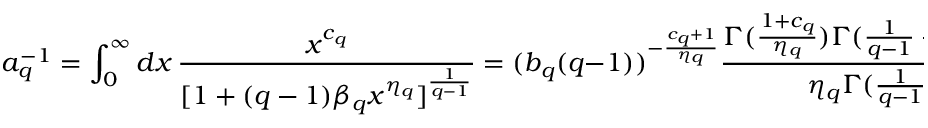Convert formula to latex. <formula><loc_0><loc_0><loc_500><loc_500>a _ { q } ^ { - 1 } = \int _ { 0 } ^ { \infty } d x \, \frac { x ^ { c _ { q } } } { [ 1 + ( q - 1 ) \beta _ { q } x ^ { \eta _ { q } } ] ^ { \frac { 1 } { q - 1 } } } = ( b _ { q } ( q - 1 ) ) ^ { - \frac { c _ { q } + 1 } { \eta _ { q } } } \frac { \Gamma ( \frac { 1 + c _ { q } } { \eta _ { q } } ) \Gamma ( \frac { 1 } { q - 1 } - \frac { 1 + c _ { q } } { \eta _ { q } } ) } { \eta _ { q } \Gamma ( \frac { 1 } { q - 1 } ) }</formula> 